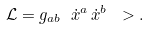Convert formula to latex. <formula><loc_0><loc_0><loc_500><loc_500>\mathcal { L } = g _ { a b } \ \dot { x } ^ { a } \, \dot { x } ^ { b } \ > .</formula> 